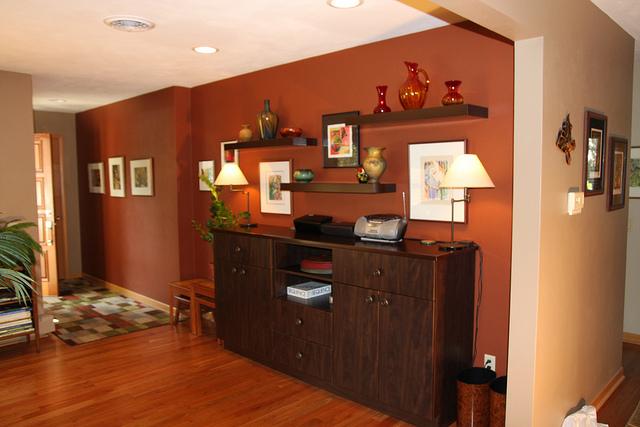What is to the right of the right lamp?
Give a very brief answer. Wall. What is displayed on the shelves?
Write a very short answer. Vases. Are the lamps turned on?
Short answer required. Yes. What color are the walls?
Write a very short answer. Brown. 